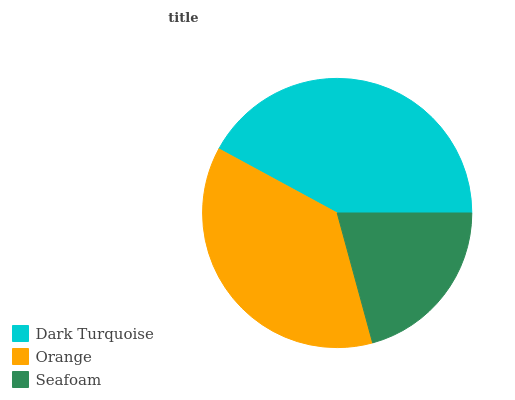Is Seafoam the minimum?
Answer yes or no. Yes. Is Dark Turquoise the maximum?
Answer yes or no. Yes. Is Orange the minimum?
Answer yes or no. No. Is Orange the maximum?
Answer yes or no. No. Is Dark Turquoise greater than Orange?
Answer yes or no. Yes. Is Orange less than Dark Turquoise?
Answer yes or no. Yes. Is Orange greater than Dark Turquoise?
Answer yes or no. No. Is Dark Turquoise less than Orange?
Answer yes or no. No. Is Orange the high median?
Answer yes or no. Yes. Is Orange the low median?
Answer yes or no. Yes. Is Dark Turquoise the high median?
Answer yes or no. No. Is Seafoam the low median?
Answer yes or no. No. 